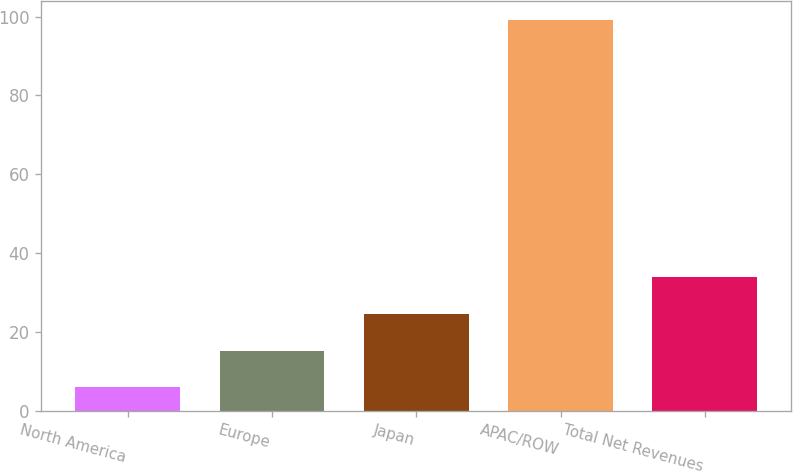Convert chart. <chart><loc_0><loc_0><loc_500><loc_500><bar_chart><fcel>North America<fcel>Europe<fcel>Japan<fcel>APAC/ROW<fcel>Total Net Revenues<nl><fcel>6<fcel>15.3<fcel>24.6<fcel>99<fcel>33.9<nl></chart> 